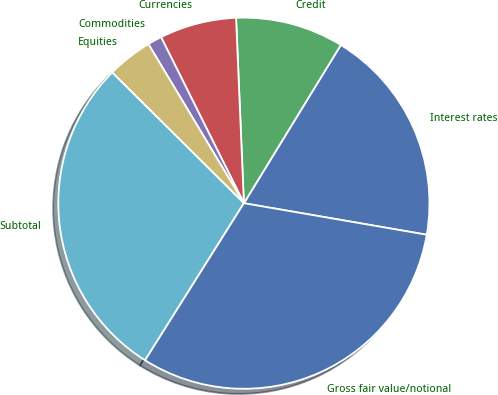Convert chart. <chart><loc_0><loc_0><loc_500><loc_500><pie_chart><fcel>Interest rates<fcel>Credit<fcel>Currencies<fcel>Commodities<fcel>Equities<fcel>Subtotal<fcel>Gross fair value/notional<nl><fcel>18.97%<fcel>9.42%<fcel>6.69%<fcel>1.24%<fcel>3.96%<fcel>28.5%<fcel>31.22%<nl></chart> 